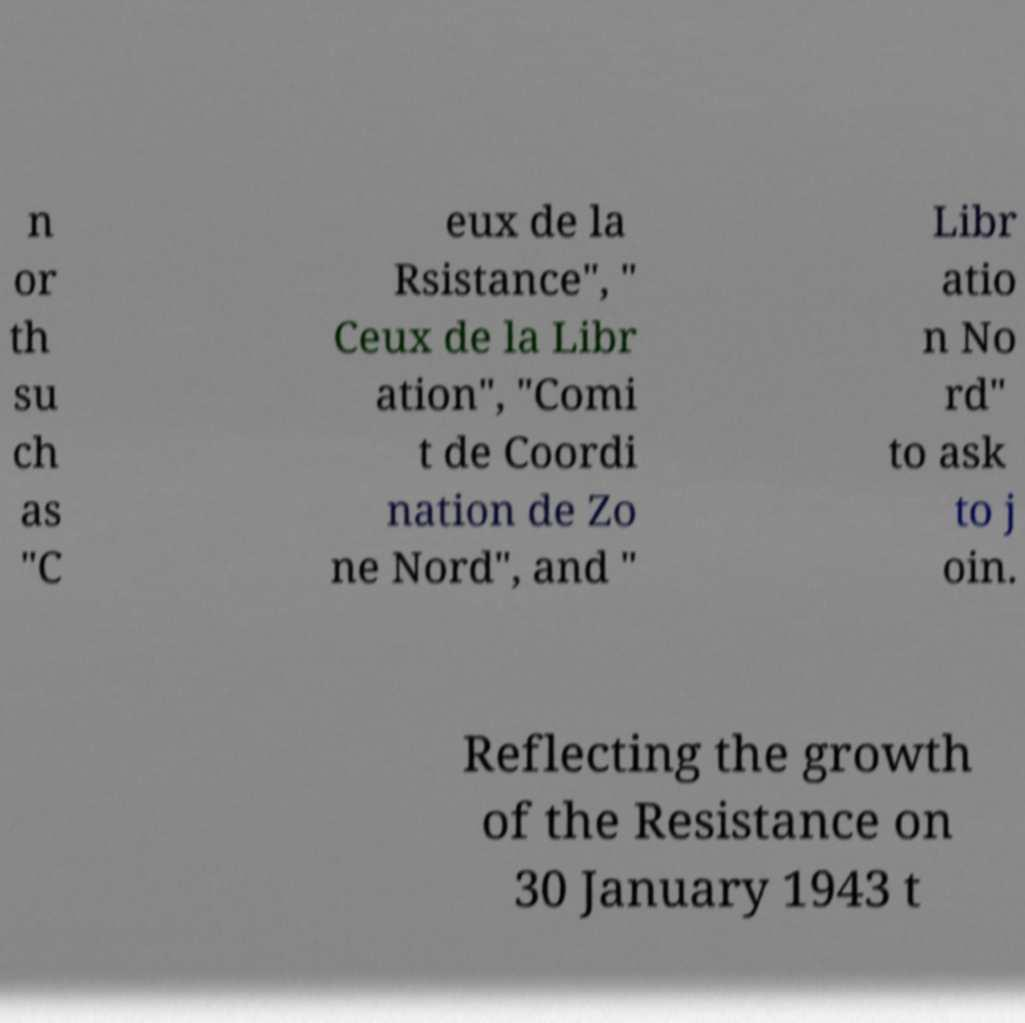Could you extract and type out the text from this image? n or th su ch as "C eux de la Rsistance", " Ceux de la Libr ation", "Comi t de Coordi nation de Zo ne Nord", and " Libr atio n No rd" to ask to j oin. Reflecting the growth of the Resistance on 30 January 1943 t 